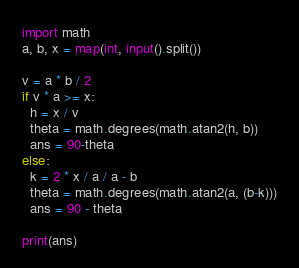<code> <loc_0><loc_0><loc_500><loc_500><_Python_>import math
a, b, x = map(int, input().split())

v = a * b / 2
if v * a >= x:
  h = x / v
  theta = math.degrees(math.atan2(h, b))
  ans = 90-theta
else:
  k = 2 * x / a / a - b
  theta = math.degrees(math.atan2(a, (b-k)))
  ans = 90 - theta
  
print(ans)</code> 